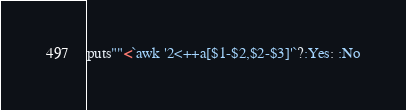Convert code to text. <code><loc_0><loc_0><loc_500><loc_500><_Ruby_>puts""<`awk '2<++a[$1-$2,$2-$3]'`?:Yes: :No</code> 